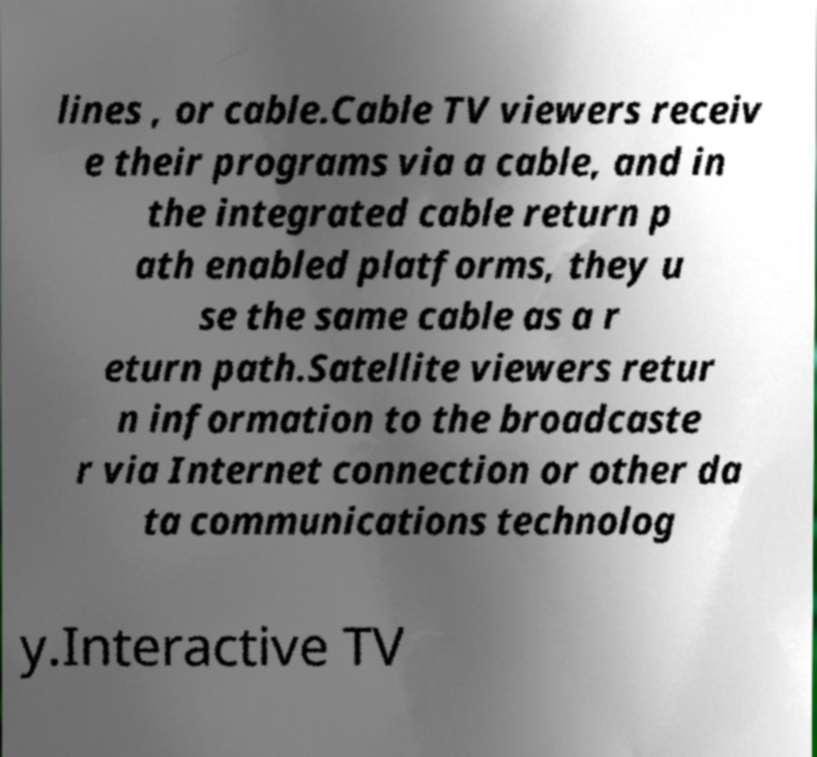Can you accurately transcribe the text from the provided image for me? lines , or cable.Cable TV viewers receiv e their programs via a cable, and in the integrated cable return p ath enabled platforms, they u se the same cable as a r eturn path.Satellite viewers retur n information to the broadcaste r via Internet connection or other da ta communications technolog y.Interactive TV 